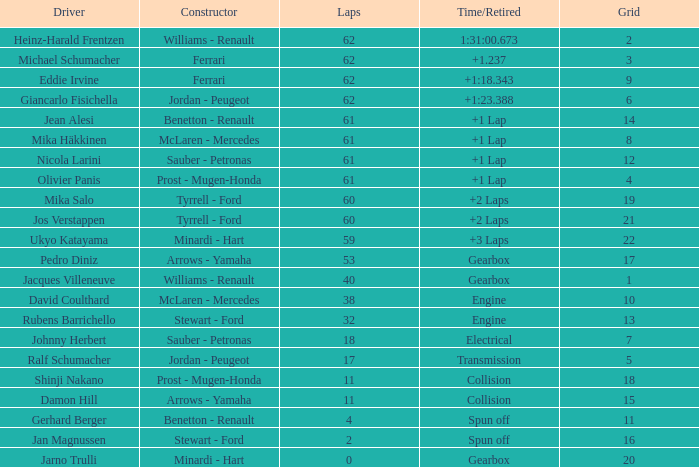Write the full table. {'header': ['Driver', 'Constructor', 'Laps', 'Time/Retired', 'Grid'], 'rows': [['Heinz-Harald Frentzen', 'Williams - Renault', '62', '1:31:00.673', '2'], ['Michael Schumacher', 'Ferrari', '62', '+1.237', '3'], ['Eddie Irvine', 'Ferrari', '62', '+1:18.343', '9'], ['Giancarlo Fisichella', 'Jordan - Peugeot', '62', '+1:23.388', '6'], ['Jean Alesi', 'Benetton - Renault', '61', '+1 Lap', '14'], ['Mika Häkkinen', 'McLaren - Mercedes', '61', '+1 Lap', '8'], ['Nicola Larini', 'Sauber - Petronas', '61', '+1 Lap', '12'], ['Olivier Panis', 'Prost - Mugen-Honda', '61', '+1 Lap', '4'], ['Mika Salo', 'Tyrrell - Ford', '60', '+2 Laps', '19'], ['Jos Verstappen', 'Tyrrell - Ford', '60', '+2 Laps', '21'], ['Ukyo Katayama', 'Minardi - Hart', '59', '+3 Laps', '22'], ['Pedro Diniz', 'Arrows - Yamaha', '53', 'Gearbox', '17'], ['Jacques Villeneuve', 'Williams - Renault', '40', 'Gearbox', '1'], ['David Coulthard', 'McLaren - Mercedes', '38', 'Engine', '10'], ['Rubens Barrichello', 'Stewart - Ford', '32', 'Engine', '13'], ['Johnny Herbert', 'Sauber - Petronas', '18', 'Electrical', '7'], ['Ralf Schumacher', 'Jordan - Peugeot', '17', 'Transmission', '5'], ['Shinji Nakano', 'Prost - Mugen-Honda', '11', 'Collision', '18'], ['Damon Hill', 'Arrows - Yamaha', '11', 'Collision', '15'], ['Gerhard Berger', 'Benetton - Renault', '4', 'Spun off', '11'], ['Jan Magnussen', 'Stewart - Ford', '2', 'Spun off', '16'], ['Jarno Trulli', 'Minardi - Hart', '0', 'Gearbox', '20']]} What is the time/retired with 60 laps and a grid 19? +2 Laps. 